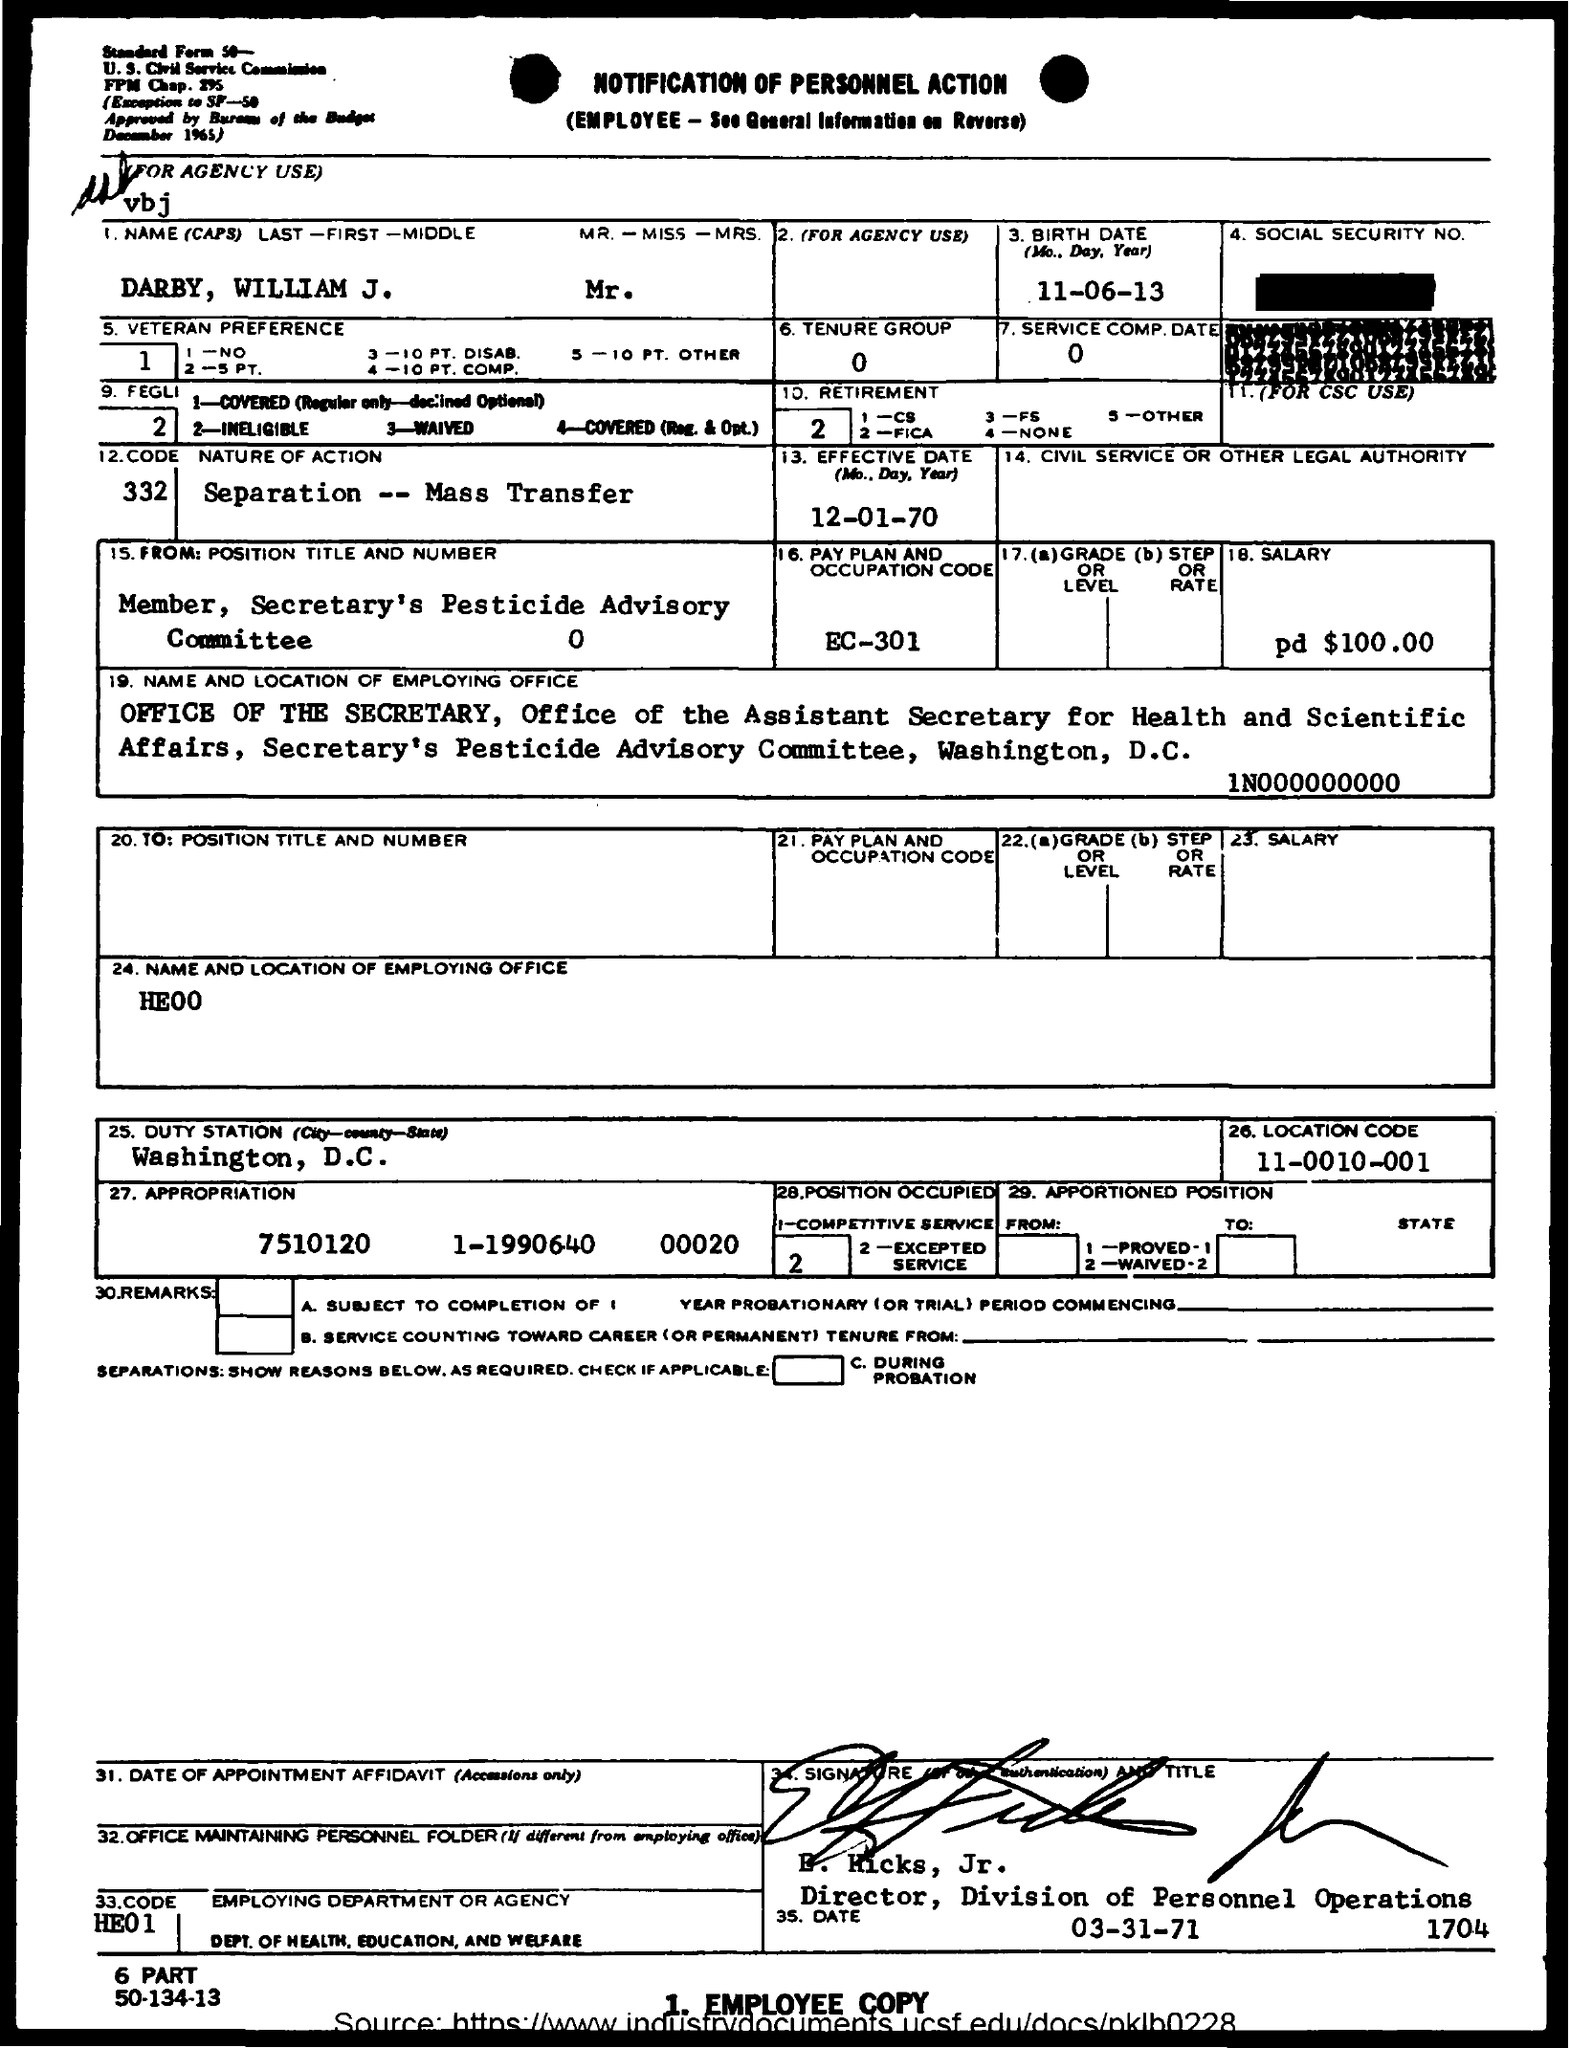What is the Name?
Give a very brief answer. Darby, William J. What is the Birth date?
Offer a terse response. 11-06-13. What is the Tenure Group?
Keep it short and to the point. 0. What is service comp. date?
Your response must be concise. 0. What is the Nature of Action?
Provide a succinct answer. Separation -- Mass Transfer. What is the Effective date?
Your response must be concise. 12-01-70. What is the Pay plan and occupation code?
Provide a succinct answer. EC-301. What is the salary?
Offer a terse response. Pd $100.00. Which is the Duty Station?
Offer a terse response. Washington, D.C. What is the Location Code?
Provide a succinct answer. 11-0010-001. 